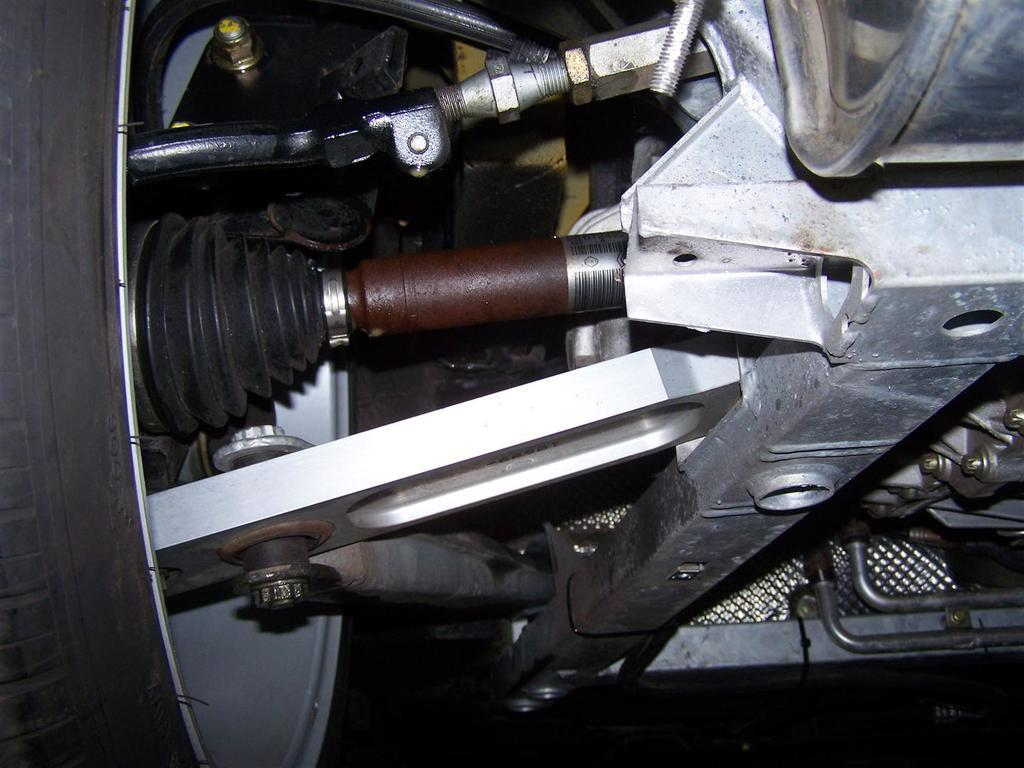What type of object can be seen in the image that is related to machinery? There is a machinery object in the image. Can you describe another object that is visible in the image? There is a tire in the image. How many fingers are visible on the machinery object in the image? There are no fingers visible on the machinery object in the image, as it is not a living being. What type of dirt can be seen on the tire in the image? There is no dirt visible on the tire in the image, as the image does not provide information about the tire's condition. 